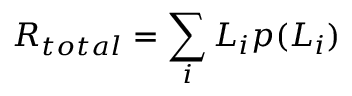Convert formula to latex. <formula><loc_0><loc_0><loc_500><loc_500>R _ { t o t a l } = \sum _ { i } L _ { i } p ( L _ { i } ) \,</formula> 